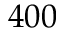<formula> <loc_0><loc_0><loc_500><loc_500>4 0 0</formula> 